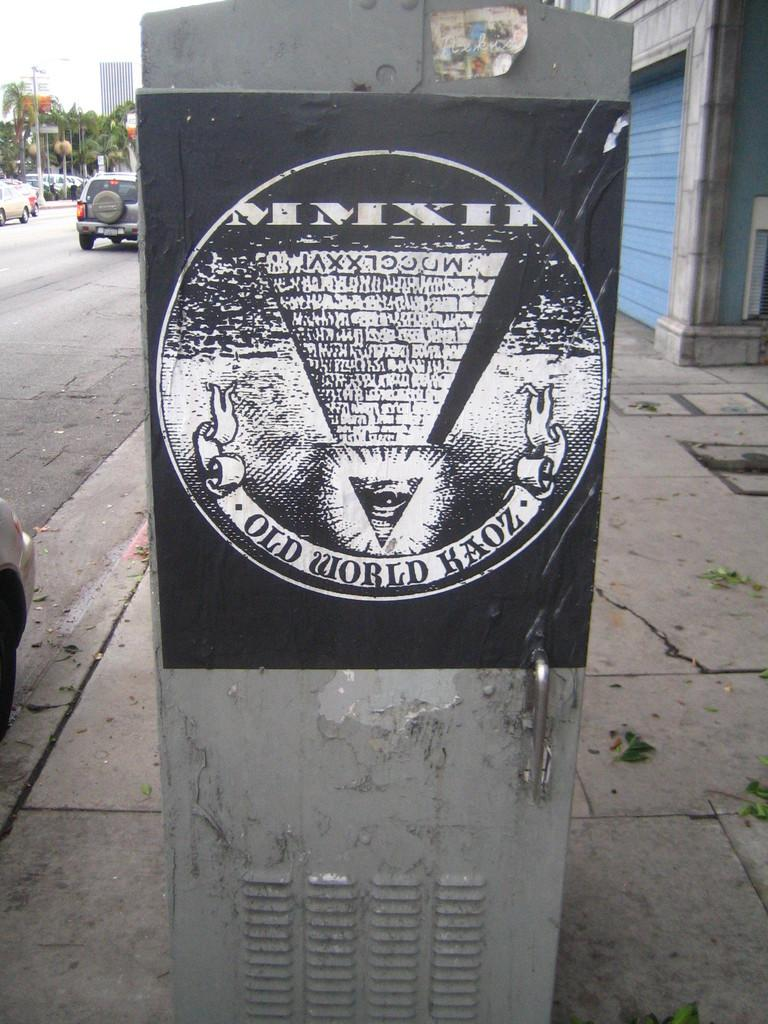<image>
Create a compact narrative representing the image presented. Poster of the Illuminati stuck to electrical box on street, including "Old World Haoz" emblazed on a scroll along the bottom. 